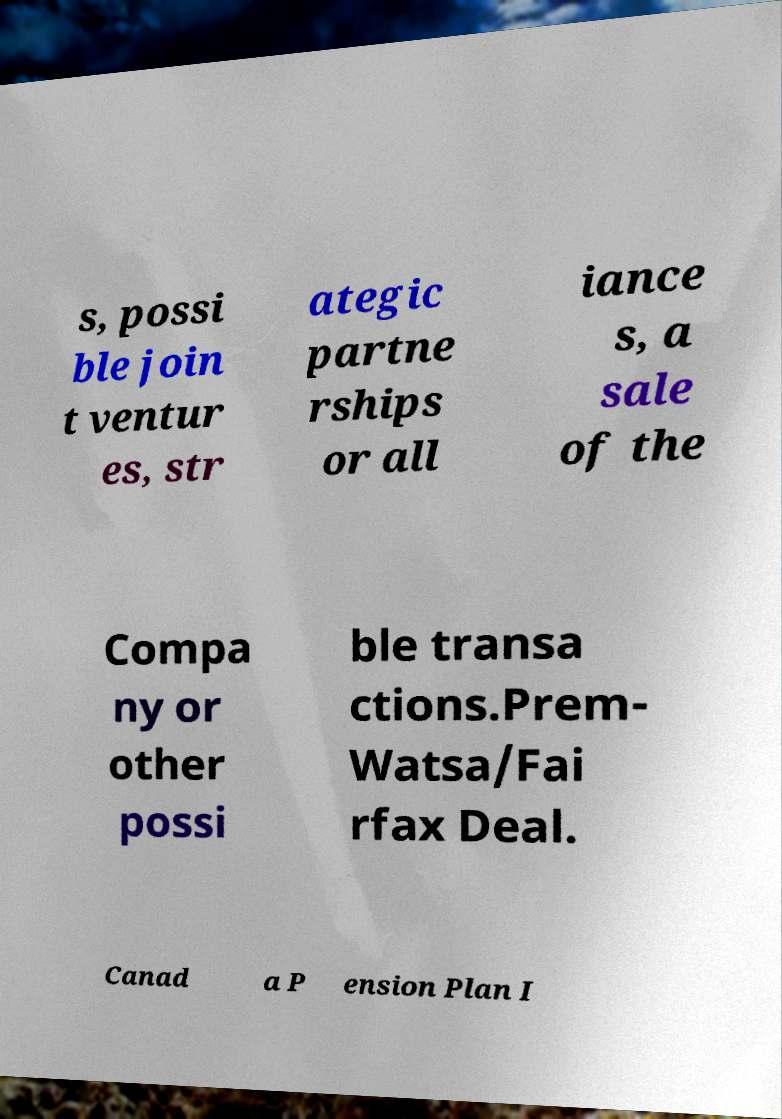Please read and relay the text visible in this image. What does it say? s, possi ble join t ventur es, str ategic partne rships or all iance s, a sale of the Compa ny or other possi ble transa ctions.Prem- Watsa/Fai rfax Deal. Canad a P ension Plan I 